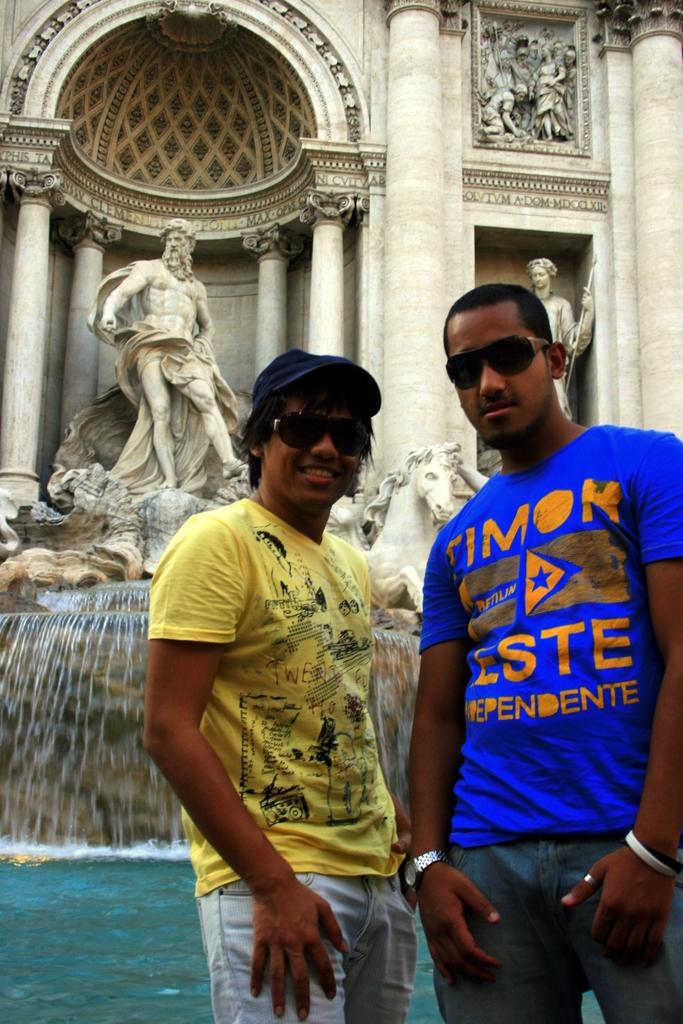How many people are in the image? There are two men standing at the bottom of the image. What is on the left side of the image? There is water on the left side of the image. What can be seen in the background of the image? There are statues in the background of the image. What type of property is being discussed in the image? There is no discussion or reference to any property in the image. 